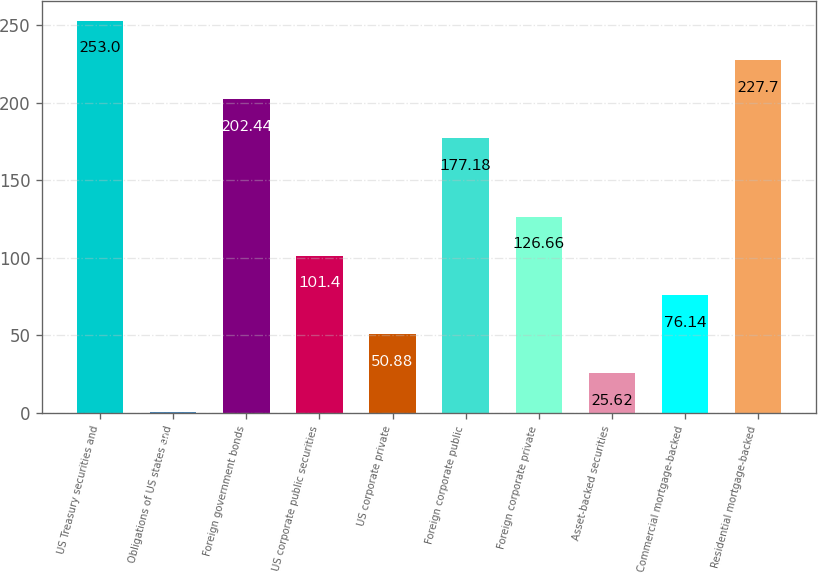<chart> <loc_0><loc_0><loc_500><loc_500><bar_chart><fcel>US Treasury securities and<fcel>Obligations of US states and<fcel>Foreign government bonds<fcel>US corporate public securities<fcel>US corporate private<fcel>Foreign corporate public<fcel>Foreign corporate private<fcel>Asset-backed securities<fcel>Commercial mortgage-backed<fcel>Residential mortgage-backed<nl><fcel>253<fcel>0.36<fcel>202.44<fcel>101.4<fcel>50.88<fcel>177.18<fcel>126.66<fcel>25.62<fcel>76.14<fcel>227.7<nl></chart> 